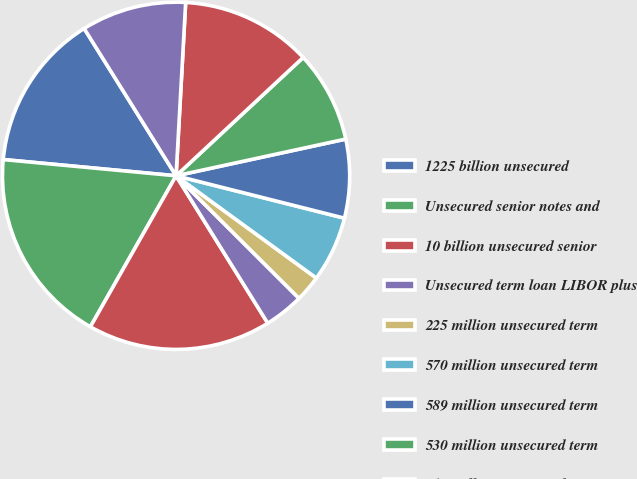Convert chart to OTSL. <chart><loc_0><loc_0><loc_500><loc_500><pie_chart><fcel>1225 billion unsecured<fcel>Unsecured senior notes and<fcel>10 billion unsecured senior<fcel>Unsecured term loan LIBOR plus<fcel>225 million unsecured term<fcel>570 million unsecured term<fcel>589 million unsecured term<fcel>530 million unsecured term<fcel>519 million unsecured term<fcel>1 420 million unsecured term<nl><fcel>14.63%<fcel>18.28%<fcel>17.07%<fcel>3.67%<fcel>2.45%<fcel>6.1%<fcel>7.32%<fcel>8.54%<fcel>12.19%<fcel>9.76%<nl></chart> 